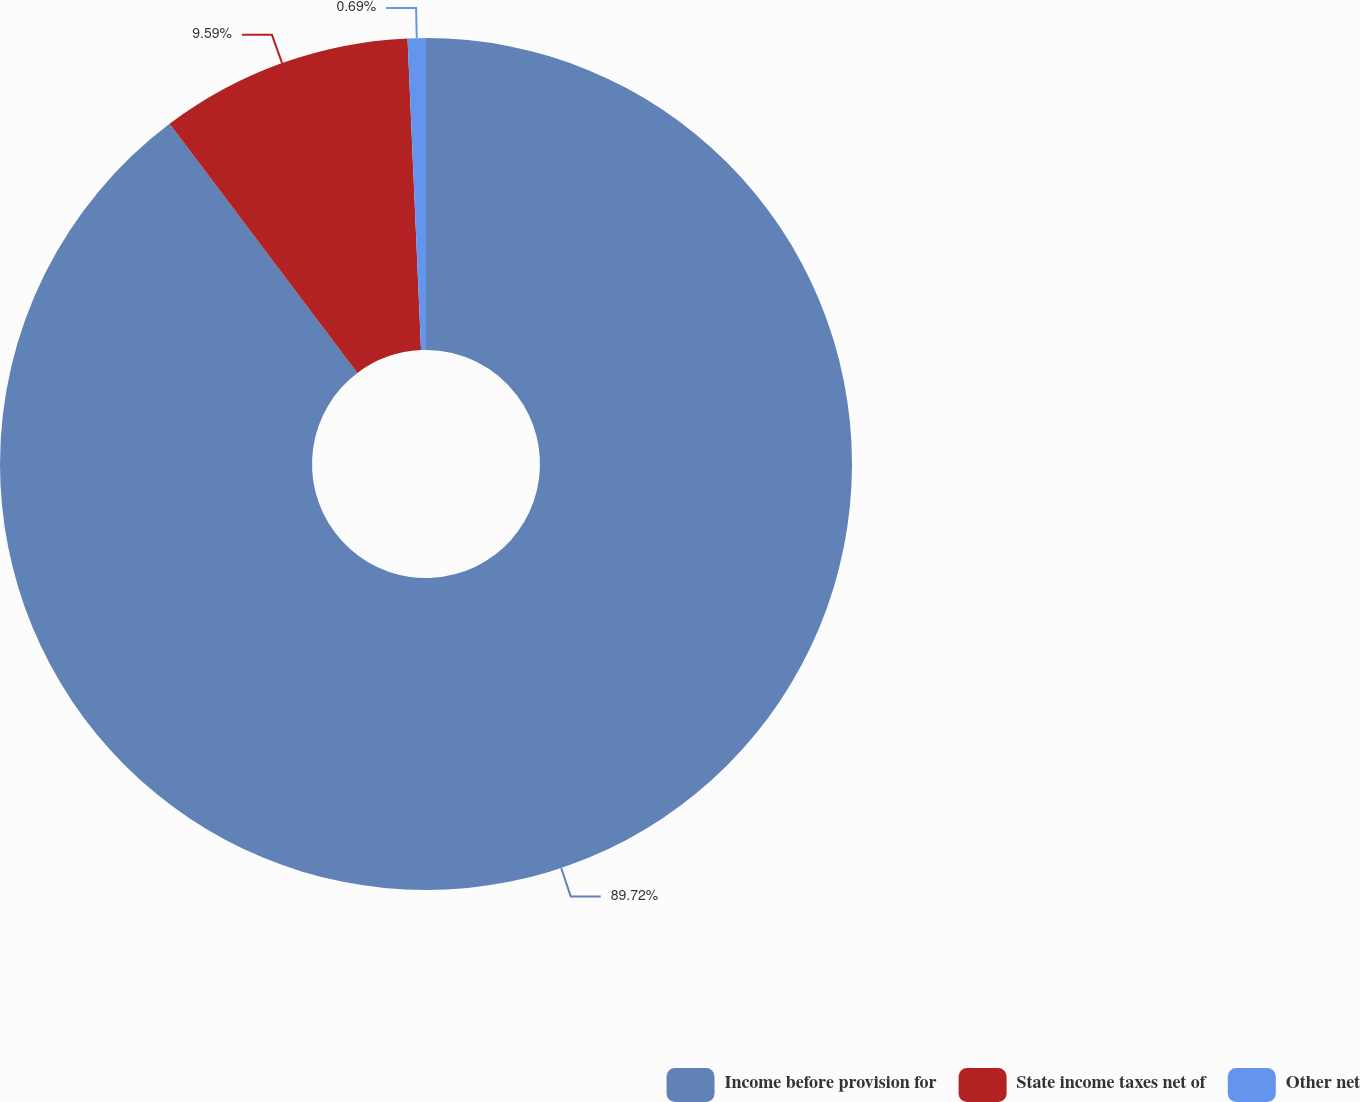<chart> <loc_0><loc_0><loc_500><loc_500><pie_chart><fcel>Income before provision for<fcel>State income taxes net of<fcel>Other net<nl><fcel>89.72%<fcel>9.59%<fcel>0.69%<nl></chart> 